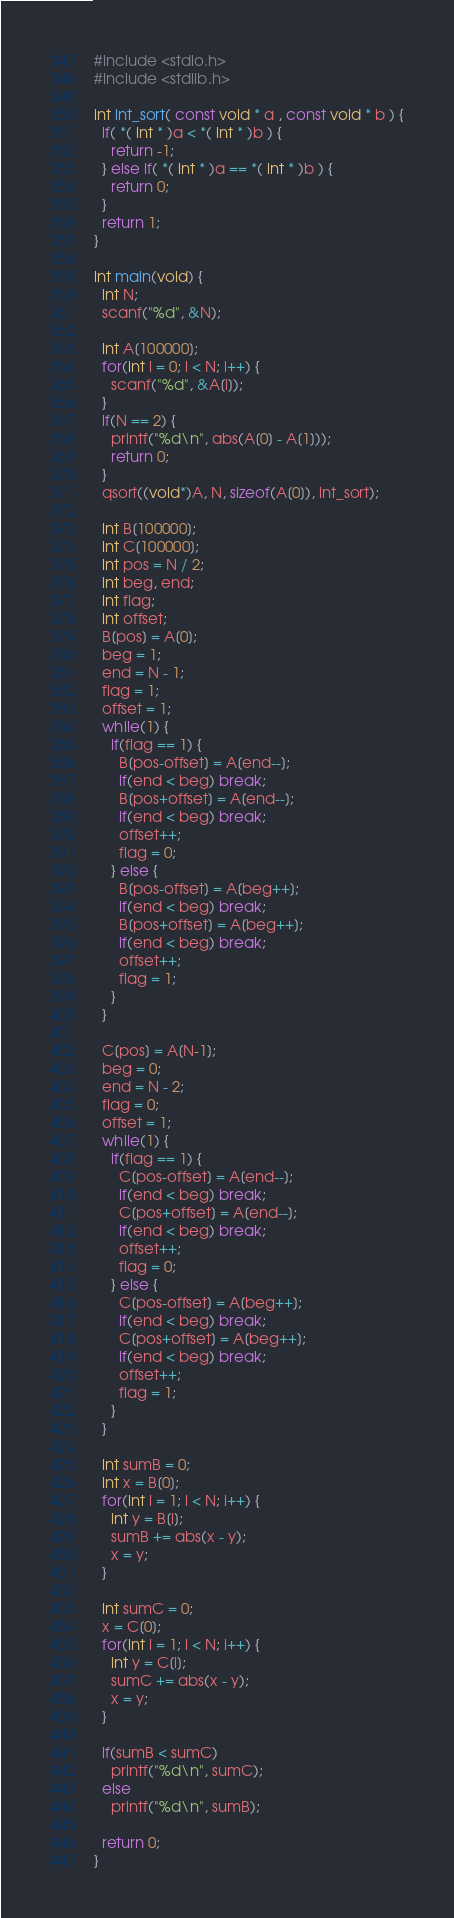<code> <loc_0><loc_0><loc_500><loc_500><_C_>#include <stdio.h>
#include <stdlib.h>

int int_sort( const void * a , const void * b ) {
  if( *( int * )a < *( int * )b ) {
    return -1;
  } else if( *( int * )a == *( int * )b ) {
    return 0;
  }
  return 1;
}

int main(void) {
  int N;
  scanf("%d", &N);

  int A[100000];
  for(int i = 0; i < N; i++) {
    scanf("%d", &A[i]);
  }
  if(N == 2) {
    printf("%d\n", abs(A[0] - A[1]));
    return 0;
  }
  qsort((void*)A, N, sizeof(A[0]), int_sort);

  int B[100000];
  int C[100000];
  int pos = N / 2;
  int beg, end;
  int flag;
  int offset;
  B[pos] = A[0];
  beg = 1;
  end = N - 1;
  flag = 1;
  offset = 1;
  while(1) {
    if(flag == 1) {
      B[pos-offset] = A[end--];
      if(end < beg) break;
      B[pos+offset] = A[end--];
      if(end < beg) break;
      offset++;
      flag = 0;
    } else {
      B[pos-offset] = A[beg++];
      if(end < beg) break;
      B[pos+offset] = A[beg++];
      if(end < beg) break;
      offset++;
      flag = 1;
    }
  }
  
  C[pos] = A[N-1];
  beg = 0;
  end = N - 2;
  flag = 0;
  offset = 1;
  while(1) {
    if(flag == 1) {
      C[pos-offset] = A[end--];
      if(end < beg) break;
      C[pos+offset] = A[end--];
      if(end < beg) break;
      offset++;
      flag = 0;
    } else {
      C[pos-offset] = A[beg++];
      if(end < beg) break;
      C[pos+offset] = A[beg++];
      if(end < beg) break;
      offset++;
      flag = 1;
    }
  }
  
  int sumB = 0;
  int x = B[0];
  for(int i = 1; i < N; i++) {
    int y = B[i];
    sumB += abs(x - y);
    x = y;
  }

  int sumC = 0;
  x = C[0];
  for(int i = 1; i < N; i++) {
    int y = C[i];
    sumC += abs(x - y);
    x = y;
  }

  if(sumB < sumC)
    printf("%d\n", sumC);
  else
    printf("%d\n", sumB);
    
  return 0;
}
</code> 